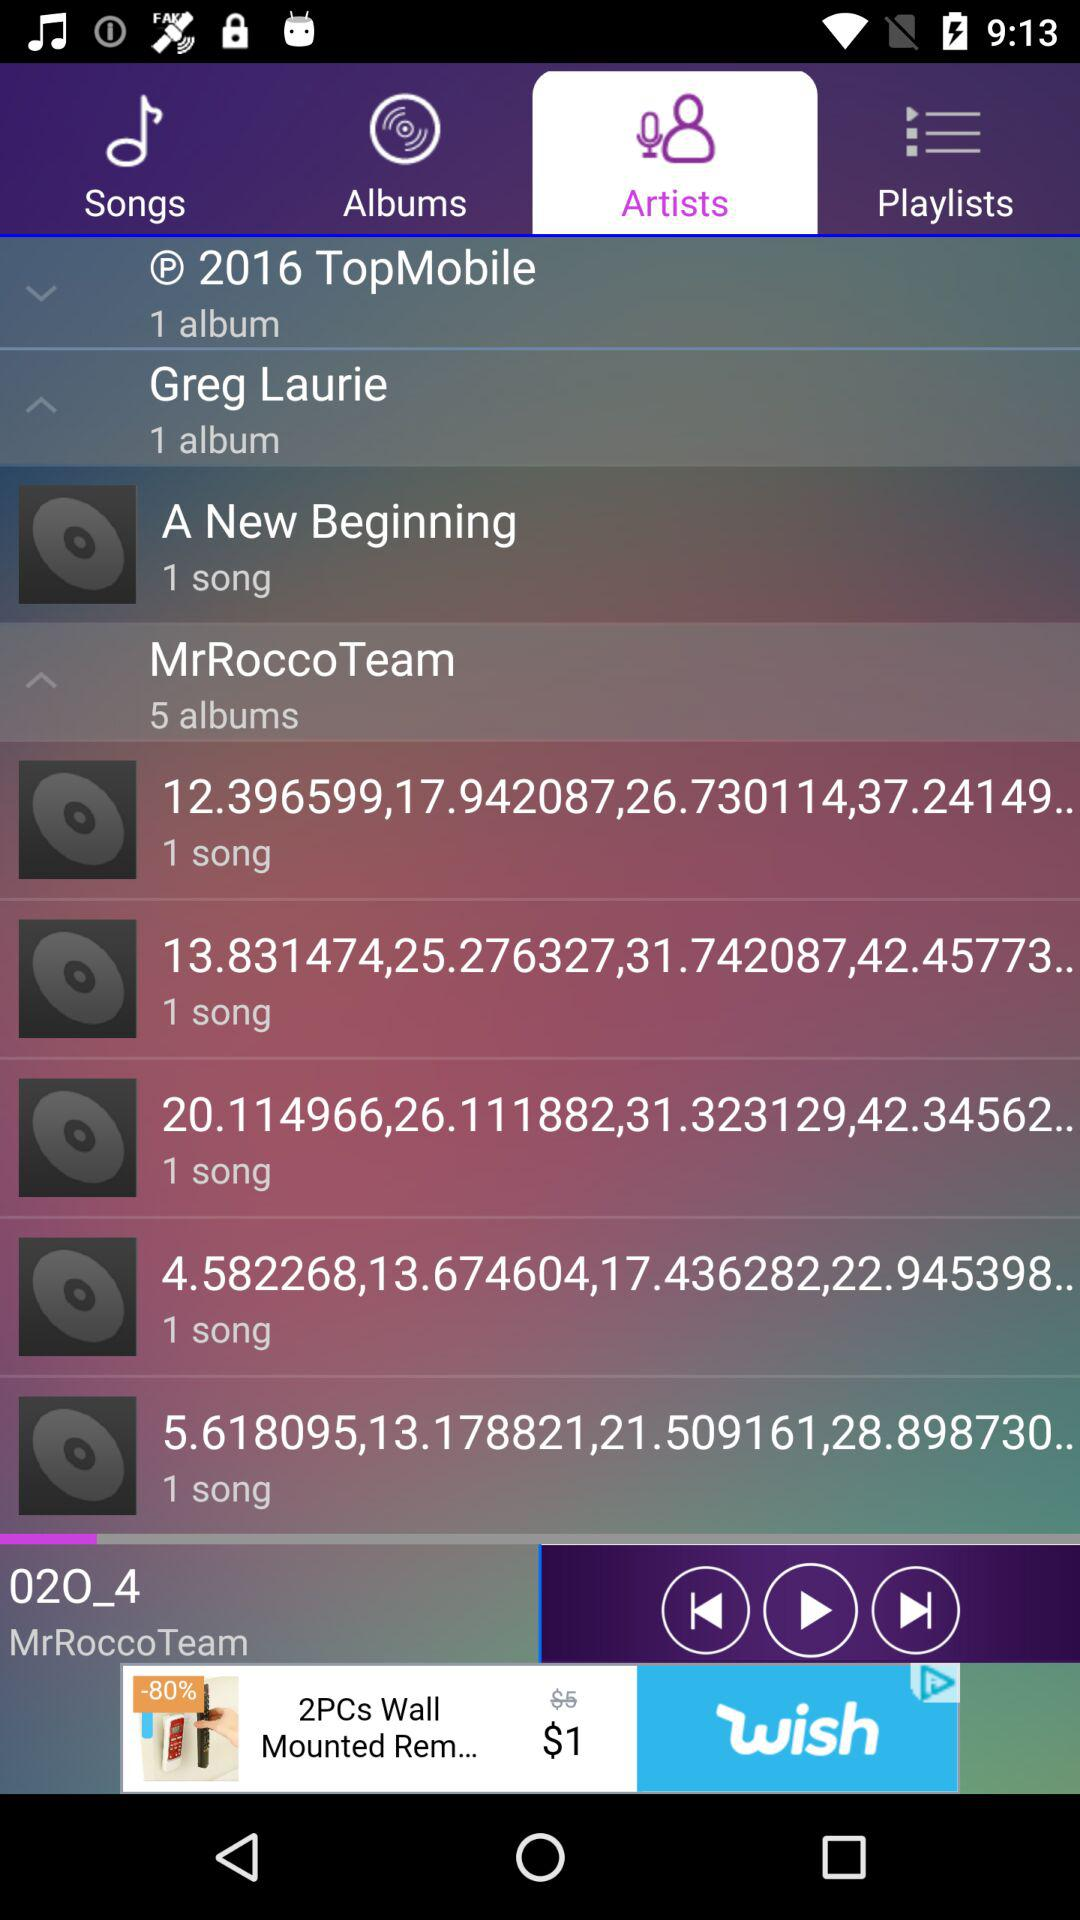How many albums does MrRocco Team have?
Answer the question using a single word or phrase. 5 